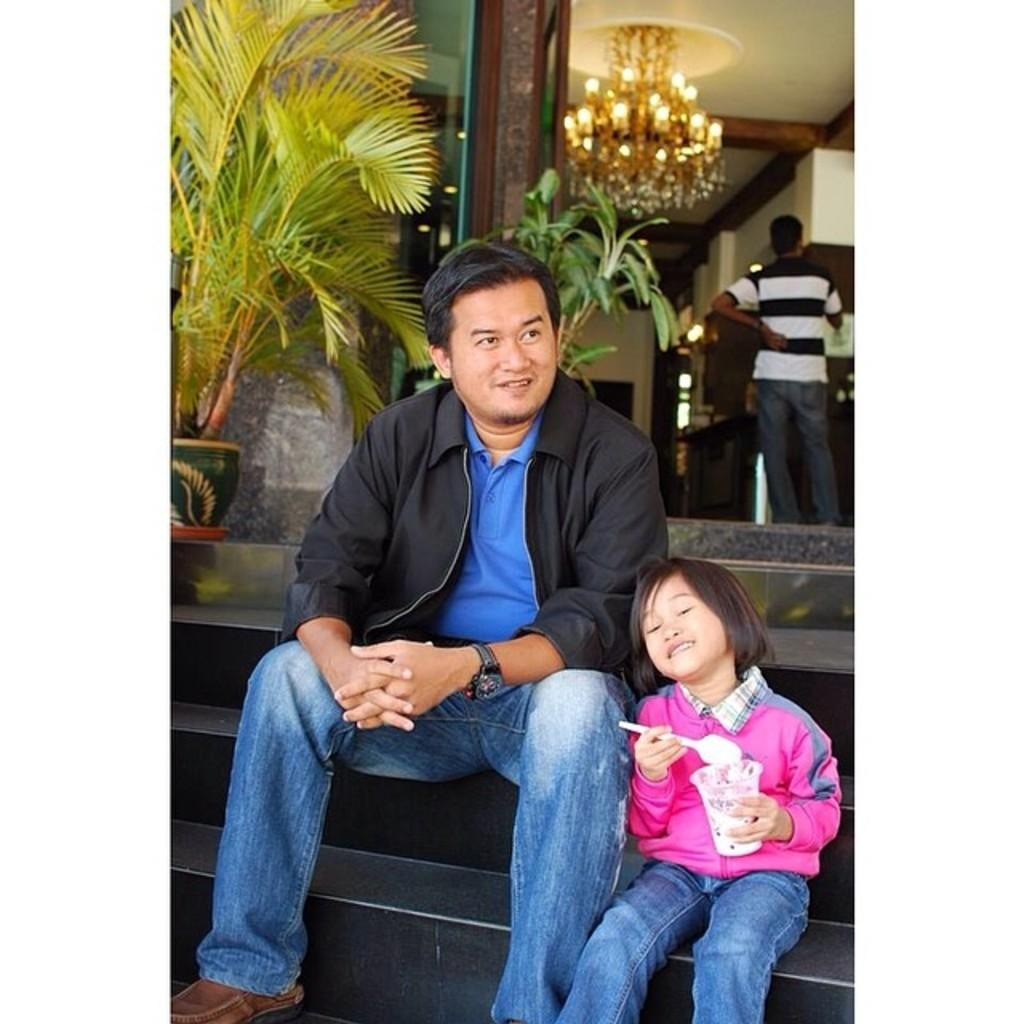Who is present in the image? There is a man and a girl in the image. What are the man and the girl doing in the image? Both the man and the girl are sitting on steps. What can be seen in the background of the image? There are plants and an entrance visible in the background. What is the man at the top of the entrance doing? The man is standing at the top of the entrance. What type of lighting fixture is present in the image? There is a chandelier in the image. How many rings is the man wearing on his left hand in the image? There is no mention of rings in the image, so we cannot determine how many rings the man is wearing. What type of hat is the girl wearing in the image? There is no hat visible on the girl in the image. 